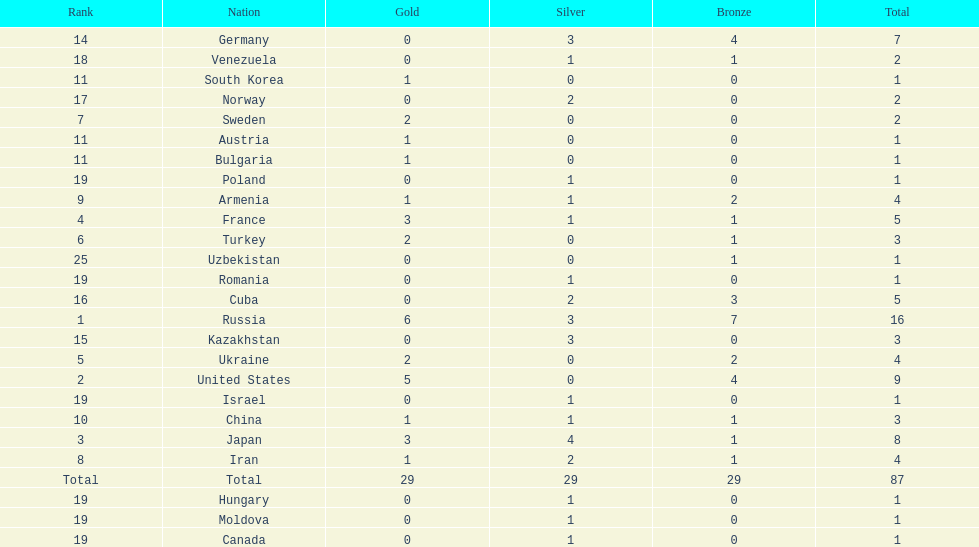What is the total amount of nations with more than 5 bronze medals? 1. 